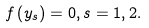Convert formula to latex. <formula><loc_0><loc_0><loc_500><loc_500>f \left ( y _ { s } \right ) = 0 , s = 1 , 2 .</formula> 